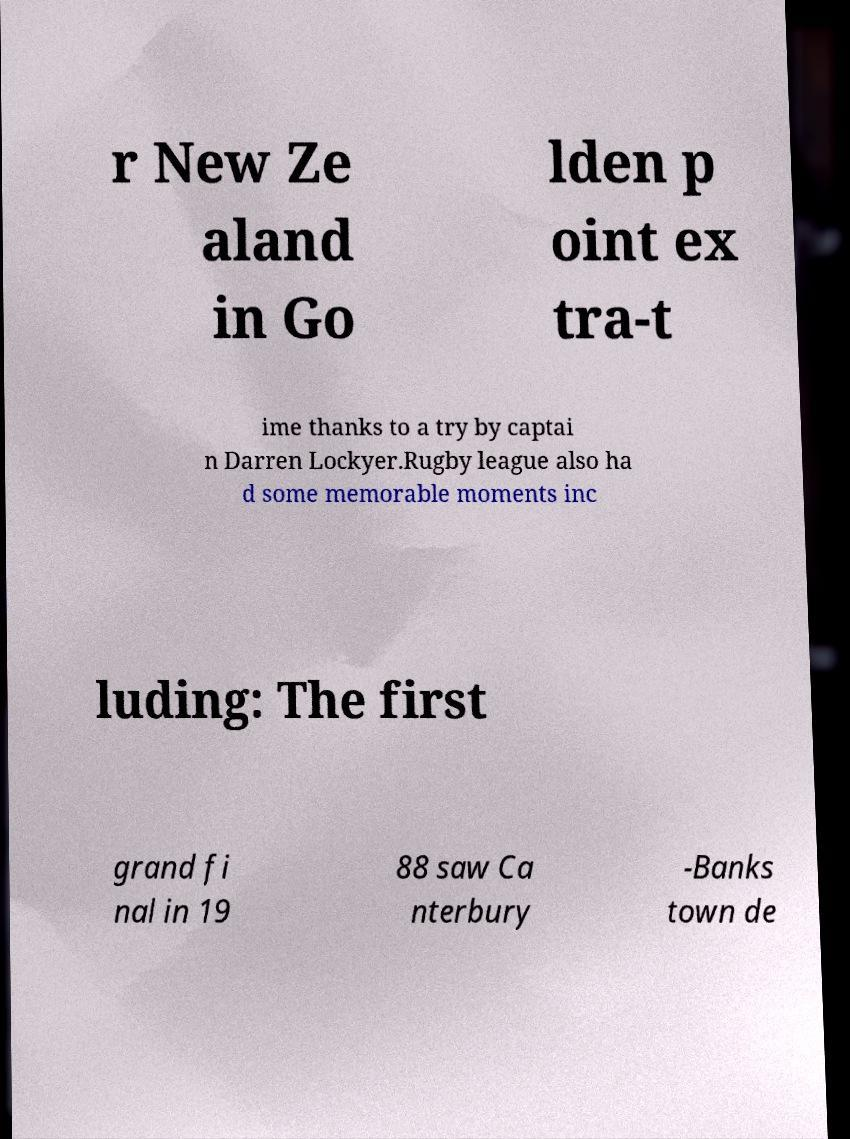Can you read and provide the text displayed in the image?This photo seems to have some interesting text. Can you extract and type it out for me? r New Ze aland in Go lden p oint ex tra-t ime thanks to a try by captai n Darren Lockyer.Rugby league also ha d some memorable moments inc luding: The first grand fi nal in 19 88 saw Ca nterbury -Banks town de 